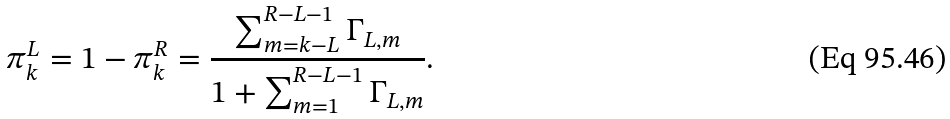<formula> <loc_0><loc_0><loc_500><loc_500>\pi _ { k } ^ { L } = 1 - \pi _ { k } ^ { R } = \frac { \sum _ { m = k - L } ^ { R - L - 1 } \Gamma _ { L , m } } { 1 + \sum _ { m = 1 } ^ { R - L - 1 } \Gamma _ { L , m } } .</formula> 